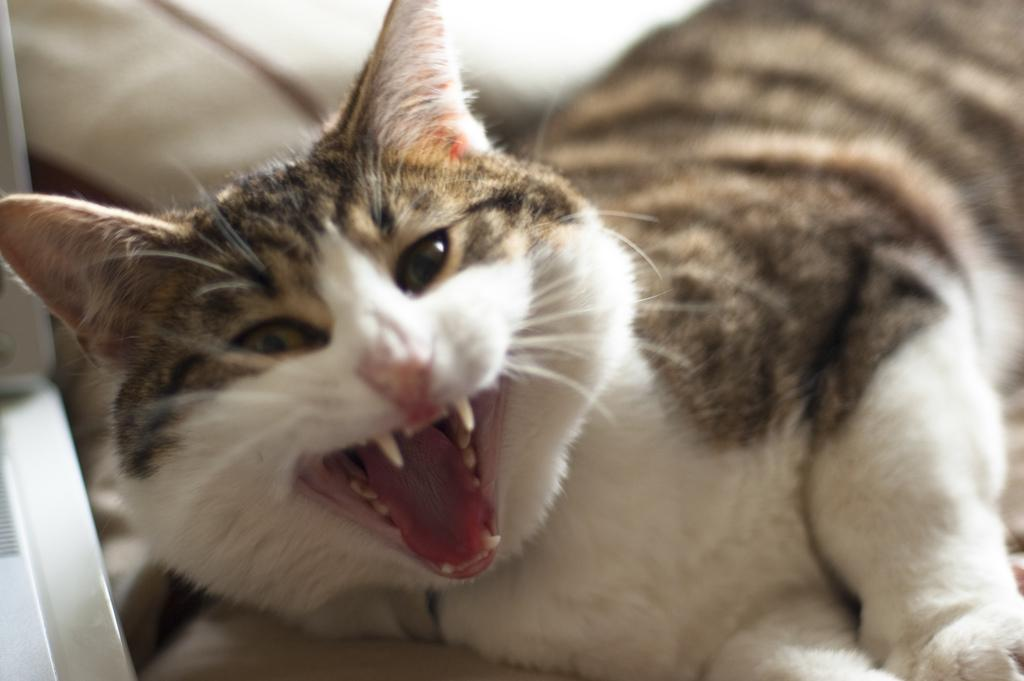What type of animal is in the image? There is a cat in the image. Can you describe the background of the image? The background of the image is blurred. What direction is the cat facing in the image? The direction the cat is facing cannot be determined from the image, as the cat's face is not clearly visible. What type of material is the canvas that the cat is sitting on? There is no canvas present in the image; it is a cat in an unspecified setting. 